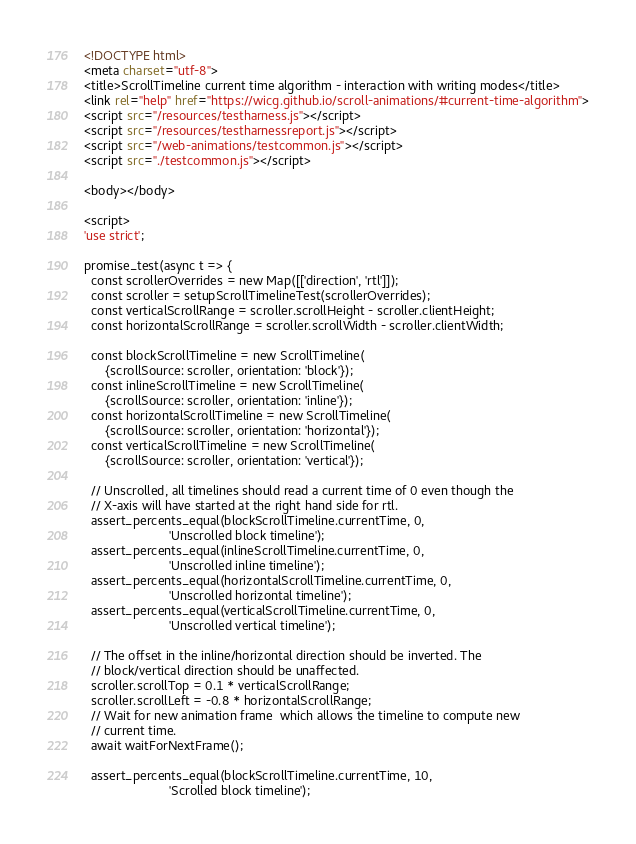<code> <loc_0><loc_0><loc_500><loc_500><_HTML_><!DOCTYPE html>
<meta charset="utf-8">
<title>ScrollTimeline current time algorithm - interaction with writing modes</title>
<link rel="help" href="https://wicg.github.io/scroll-animations/#current-time-algorithm">
<script src="/resources/testharness.js"></script>
<script src="/resources/testharnessreport.js"></script>
<script src="/web-animations/testcommon.js"></script>
<script src="./testcommon.js"></script>

<body></body>

<script>
'use strict';

promise_test(async t => {
  const scrollerOverrides = new Map([['direction', 'rtl']]);
  const scroller = setupScrollTimelineTest(scrollerOverrides);
  const verticalScrollRange = scroller.scrollHeight - scroller.clientHeight;
  const horizontalScrollRange = scroller.scrollWidth - scroller.clientWidth;

  const blockScrollTimeline = new ScrollTimeline(
      {scrollSource: scroller, orientation: 'block'});
  const inlineScrollTimeline = new ScrollTimeline(
      {scrollSource: scroller, orientation: 'inline'});
  const horizontalScrollTimeline = new ScrollTimeline(
      {scrollSource: scroller, orientation: 'horizontal'});
  const verticalScrollTimeline = new ScrollTimeline(
      {scrollSource: scroller, orientation: 'vertical'});

  // Unscrolled, all timelines should read a current time of 0 even though the
  // X-axis will have started at the right hand side for rtl.
  assert_percents_equal(blockScrollTimeline.currentTime, 0,
                        'Unscrolled block timeline');
  assert_percents_equal(inlineScrollTimeline.currentTime, 0,
                        'Unscrolled inline timeline');
  assert_percents_equal(horizontalScrollTimeline.currentTime, 0,
                        'Unscrolled horizontal timeline');
  assert_percents_equal(verticalScrollTimeline.currentTime, 0,
                        'Unscrolled vertical timeline');

  // The offset in the inline/horizontal direction should be inverted. The
  // block/vertical direction should be unaffected.
  scroller.scrollTop = 0.1 * verticalScrollRange;
  scroller.scrollLeft = -0.8 * horizontalScrollRange;
  // Wait for new animation frame  which allows the timeline to compute new
  // current time.
  await waitForNextFrame();

  assert_percents_equal(blockScrollTimeline.currentTime, 10,
                        'Scrolled block timeline');</code> 